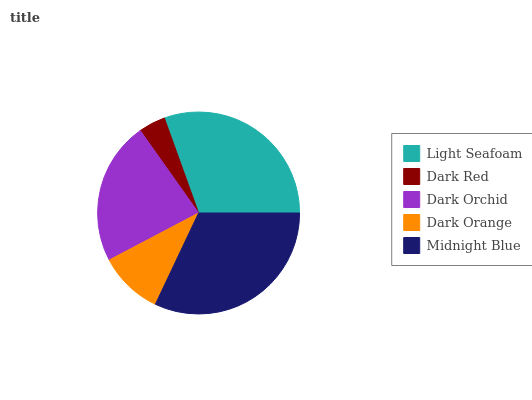Is Dark Red the minimum?
Answer yes or no. Yes. Is Midnight Blue the maximum?
Answer yes or no. Yes. Is Dark Orchid the minimum?
Answer yes or no. No. Is Dark Orchid the maximum?
Answer yes or no. No. Is Dark Orchid greater than Dark Red?
Answer yes or no. Yes. Is Dark Red less than Dark Orchid?
Answer yes or no. Yes. Is Dark Red greater than Dark Orchid?
Answer yes or no. No. Is Dark Orchid less than Dark Red?
Answer yes or no. No. Is Dark Orchid the high median?
Answer yes or no. Yes. Is Dark Orchid the low median?
Answer yes or no. Yes. Is Dark Red the high median?
Answer yes or no. No. Is Midnight Blue the low median?
Answer yes or no. No. 